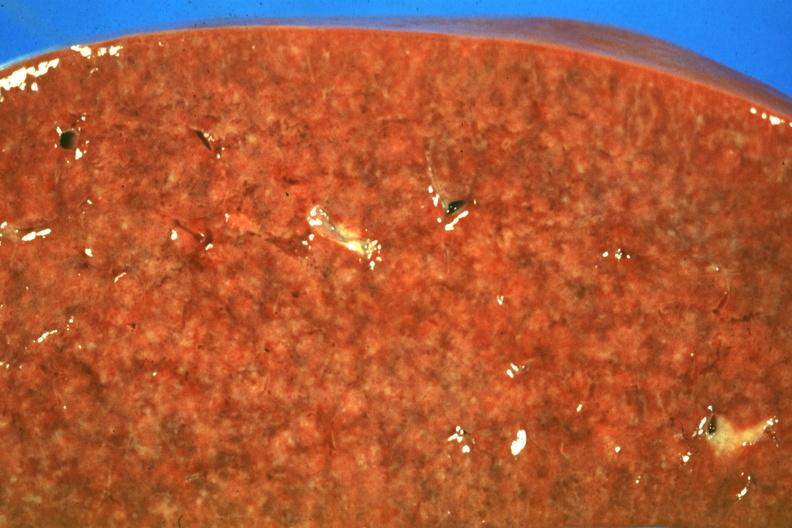what is present?
Answer the question using a single word or phrase. Hematologic 